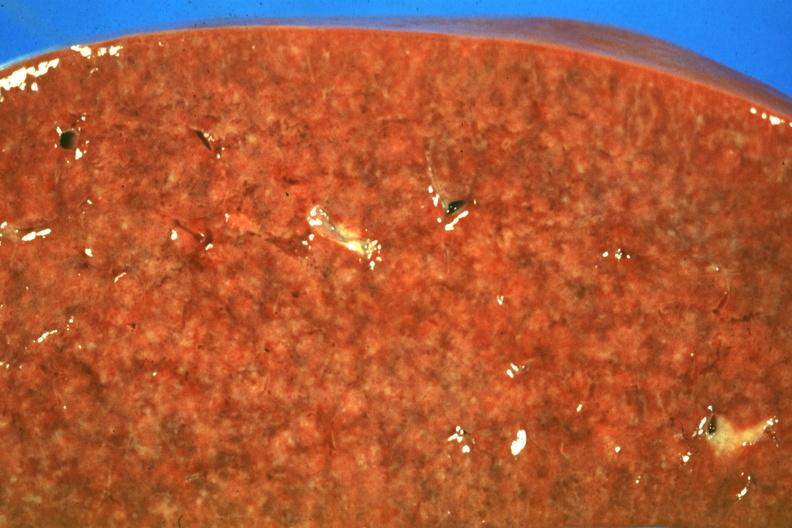what is present?
Answer the question using a single word or phrase. Hematologic 